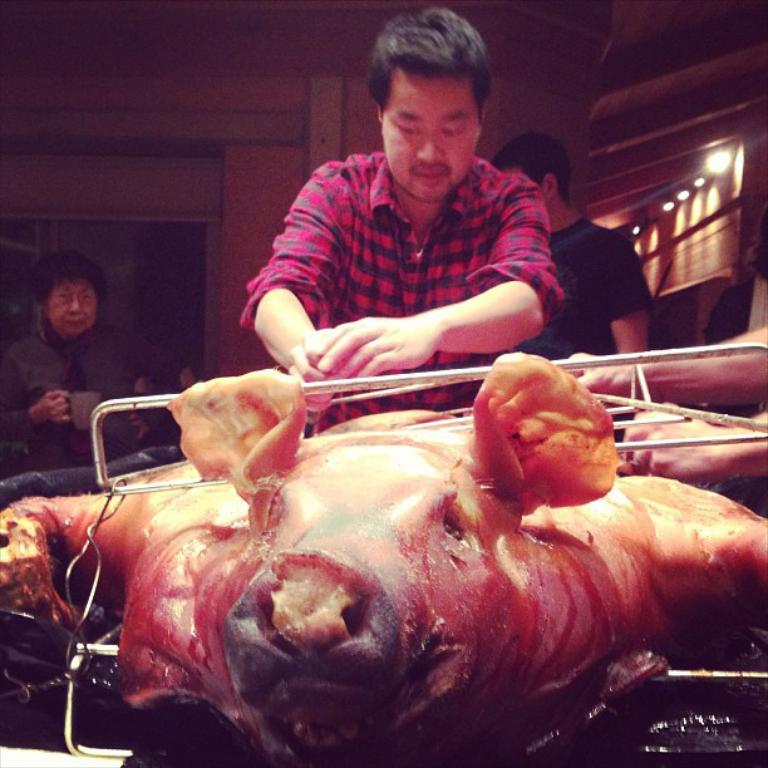What type of food is visible in the image? There is meat in the image. What objects can be seen besides the food? There are rods in the image. Are there any people present in the image? Yes, there are people in the image. Can you describe the person holding a cup? There is a person holding a cup in the image. What can be seen in the background of the image? There are lights, a wall, and some objects in the background of the image. What type of furniture is visible in the image? There is no furniture present in the image. Can you tell me what color the crayon is in the image? There is no crayon present in the image. 